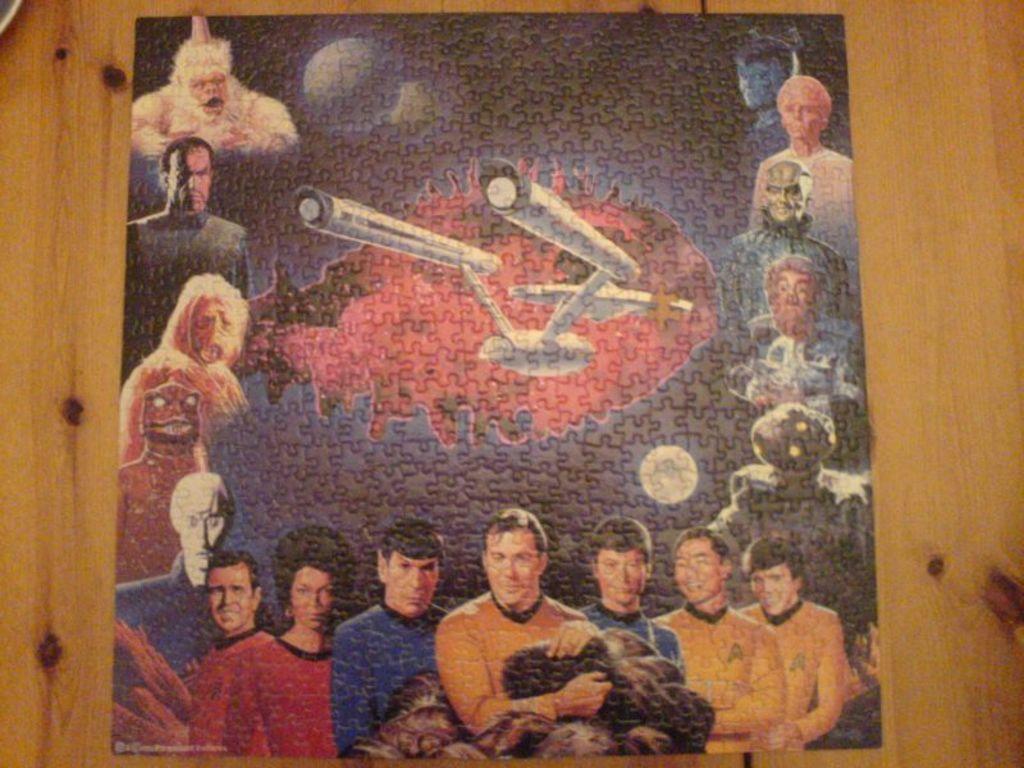Describe this image in one or two sentences. In this image we can see a puzzle card on a platform and on the puzzle card we can see the pictures of persons, plane, moon and aliens. 